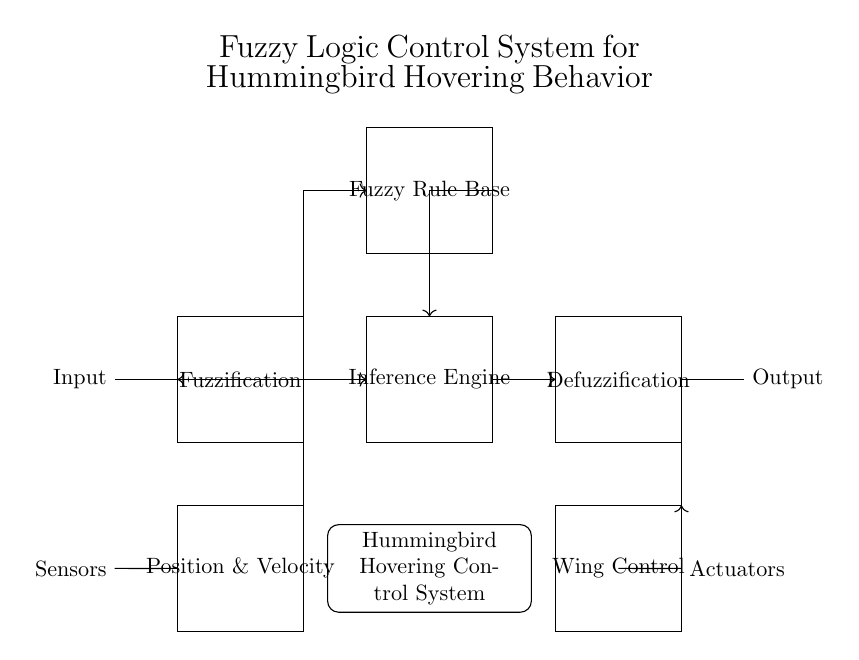What is the main purpose of this control system? The main purpose is to mimic the hovering behavior of hummingbirds using fuzzy logic. This can be inferred from the title displayed at the top of the diagram which outlines the system's objective.
Answer: mimic the hovering behavior of hummingbirds What are the main functional blocks in this fuzzy logic control system? The main functional blocks include Fuzzification, Fuzzy Rule Base, Inference Engine, Defuzzification, and Hummingbird Hovering Control System as seen in the circuit diagram. Each block performs a specific function essential for controlling the system.
Answer: Fuzzification, Fuzzy Rule Base, Inference Engine, Defuzzification How do the sensors and actuators connect in this system? The sensors connect to the input for Position & Velocity, and the actuators receive output from the Defuzzification block that controls the Wing Control. This shows a feedback loop essential for maintaining stability in hovering behavior.
Answer: Sensors to input and actuators from output What role does the Fuzzy Rule Base play in this circuit? The Fuzzy Rule Base processes the inputs from the Fuzzification block to generate rules for the Inference Engine, determining how to adjust the wing control based on the imprecise data collected from sensors about the hummingbird's state.
Answer: Generates rules for inference In this circuit, what type of control mechanism is primarily employed? The control mechanism used is Fuzzy Logic Control, which is tailored to handle imprecise and uncertain information, making it suitable for mimicking the complex flight dynamics of hummingbirds. This is indicated clearly by the terminology used throughout the diagram.
Answer: Fuzzy Logic Control 